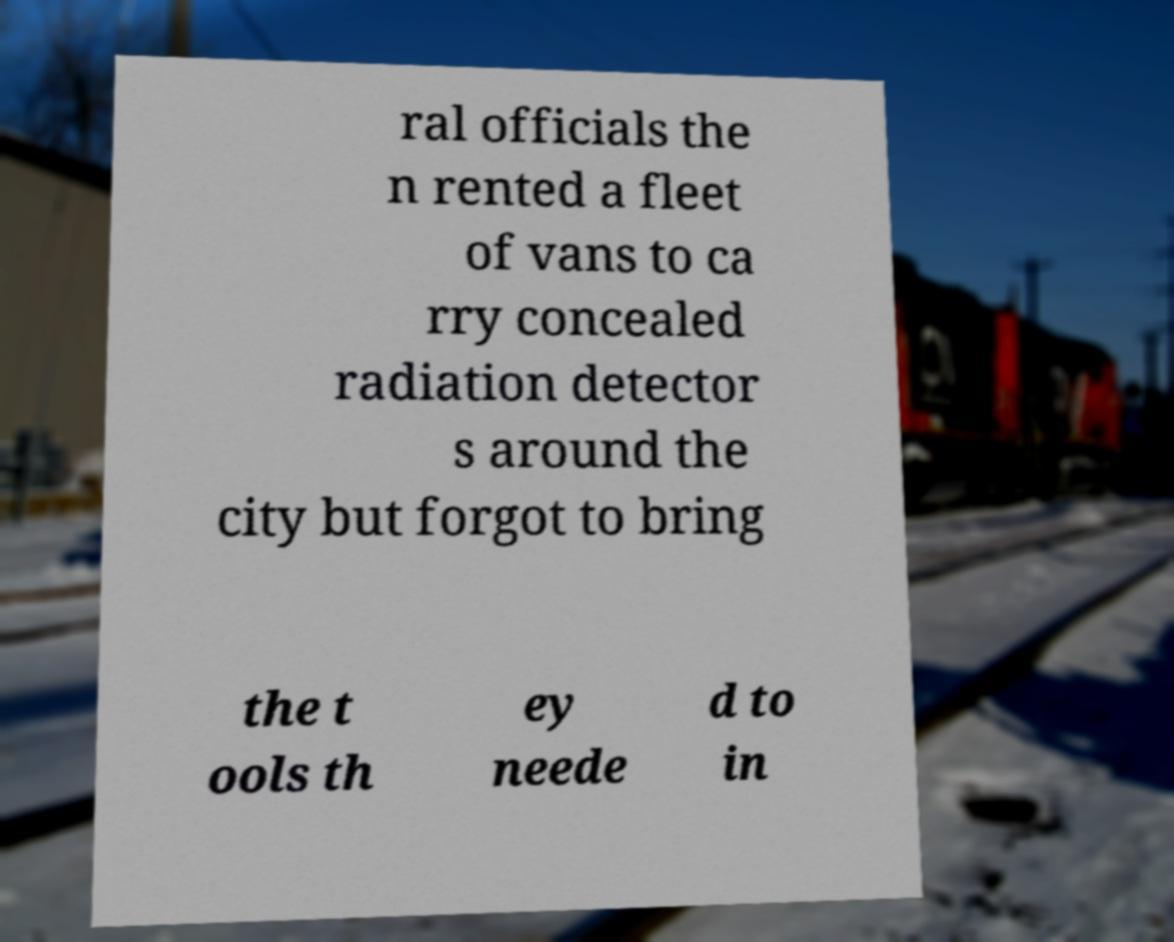Can you accurately transcribe the text from the provided image for me? ral officials the n rented a fleet of vans to ca rry concealed radiation detector s around the city but forgot to bring the t ools th ey neede d to in 